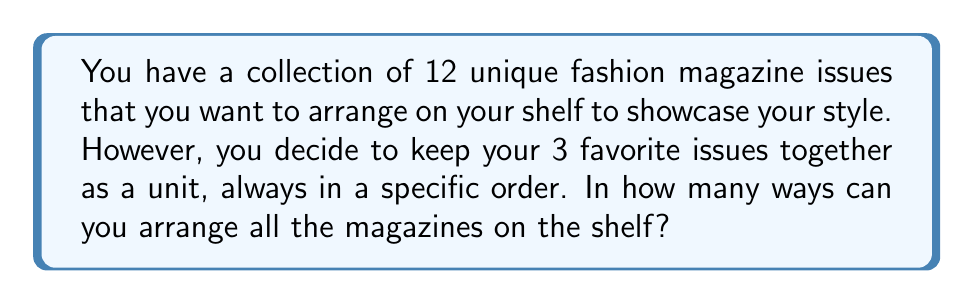Can you answer this question? Let's approach this step-by-step:

1) First, we need to consider the 3 favorite issues as a single unit. This means we now have 10 items to arrange:
   - 9 individual magazines
   - 1 unit of 3 favorite magazines

2) The number of ways to arrange 10 distinct items is a straightforward permutation:

   $$P(10,10) = 10!$$

3) However, we're not done yet. The 3 favorite issues within their unit can also be arranged in different ways relative to the shelf. They can be placed with the spine facing outward or inward.

4) This gives us 2 possible orientations for the unit of 3 favorite issues.

5) By the multiplication principle, we multiply the number of arrangements of the 10 items by the number of orientations of the favorite issue unit:

   $$\text{Total arrangements} = 10! \times 2$$

6) Calculate:
   $$10! \times 2 = 3,628,800 \times 2 = 7,257,600$$

Therefore, there are 7,257,600 ways to arrange the magazines on the shelf.
Answer: 7,257,600 